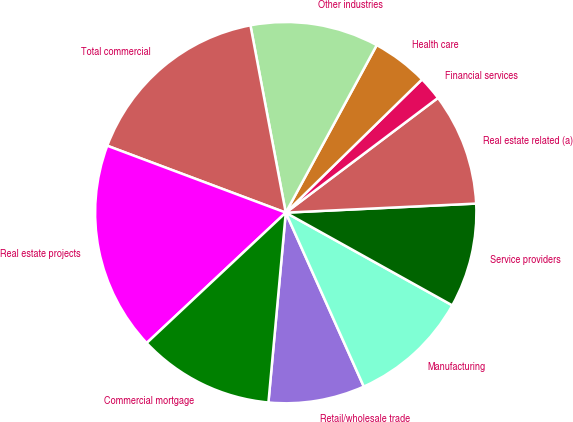Convert chart to OTSL. <chart><loc_0><loc_0><loc_500><loc_500><pie_chart><fcel>Retail/wholesale trade<fcel>Manufacturing<fcel>Service providers<fcel>Real estate related (a)<fcel>Financial services<fcel>Health care<fcel>Other industries<fcel>Total commercial<fcel>Real estate projects<fcel>Commercial mortgage<nl><fcel>8.16%<fcel>10.2%<fcel>8.84%<fcel>9.52%<fcel>2.04%<fcel>4.76%<fcel>10.88%<fcel>16.32%<fcel>17.69%<fcel>11.56%<nl></chart> 